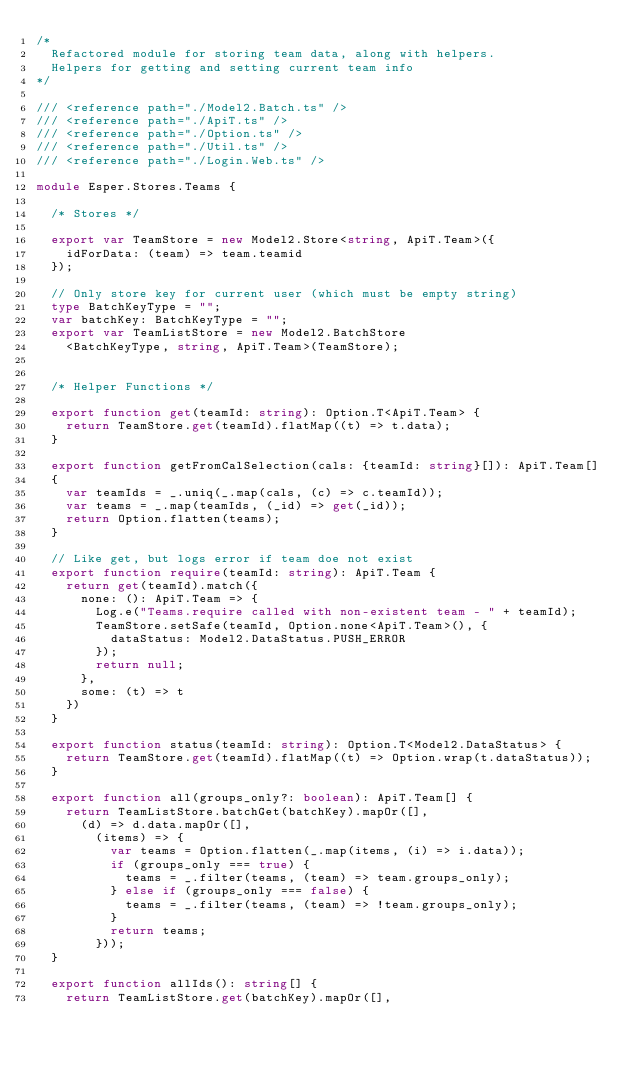Convert code to text. <code><loc_0><loc_0><loc_500><loc_500><_TypeScript_>/*
  Refactored module for storing team data, along with helpers.
  Helpers for getting and setting current team info
*/

/// <reference path="./Model2.Batch.ts" />
/// <reference path="./ApiT.ts" />
/// <reference path="./Option.ts" />
/// <reference path="./Util.ts" />
/// <reference path="./Login.Web.ts" />

module Esper.Stores.Teams {

  /* Stores */

  export var TeamStore = new Model2.Store<string, ApiT.Team>({
    idForData: (team) => team.teamid
  });

  // Only store key for current user (which must be empty string)
  type BatchKeyType = "";
  var batchKey: BatchKeyType = "";
  export var TeamListStore = new Model2.BatchStore
    <BatchKeyType, string, ApiT.Team>(TeamStore);


  /* Helper Functions */

  export function get(teamId: string): Option.T<ApiT.Team> {
    return TeamStore.get(teamId).flatMap((t) => t.data);
  }

  export function getFromCalSelection(cals: {teamId: string}[]): ApiT.Team[]
  {
    var teamIds = _.uniq(_.map(cals, (c) => c.teamId));
    var teams = _.map(teamIds, (_id) => get(_id));
    return Option.flatten(teams);
  }

  // Like get, but logs error if team doe not exist
  export function require(teamId: string): ApiT.Team {
    return get(teamId).match({
      none: (): ApiT.Team => {
        Log.e("Teams.require called with non-existent team - " + teamId);
        TeamStore.setSafe(teamId, Option.none<ApiT.Team>(), {
          dataStatus: Model2.DataStatus.PUSH_ERROR
        });
        return null;
      },
      some: (t) => t
    })
  }

  export function status(teamId: string): Option.T<Model2.DataStatus> {
    return TeamStore.get(teamId).flatMap((t) => Option.wrap(t.dataStatus));
  }

  export function all(groups_only?: boolean): ApiT.Team[] {
    return TeamListStore.batchGet(batchKey).mapOr([],
      (d) => d.data.mapOr([],
        (items) => {
          var teams = Option.flatten(_.map(items, (i) => i.data));
          if (groups_only === true) {
            teams = _.filter(teams, (team) => team.groups_only);
          } else if (groups_only === false) {
            teams = _.filter(teams, (team) => !team.groups_only);
          }
          return teams;
        }));
  }

  export function allIds(): string[] {
    return TeamListStore.get(batchKey).mapOr([],</code> 